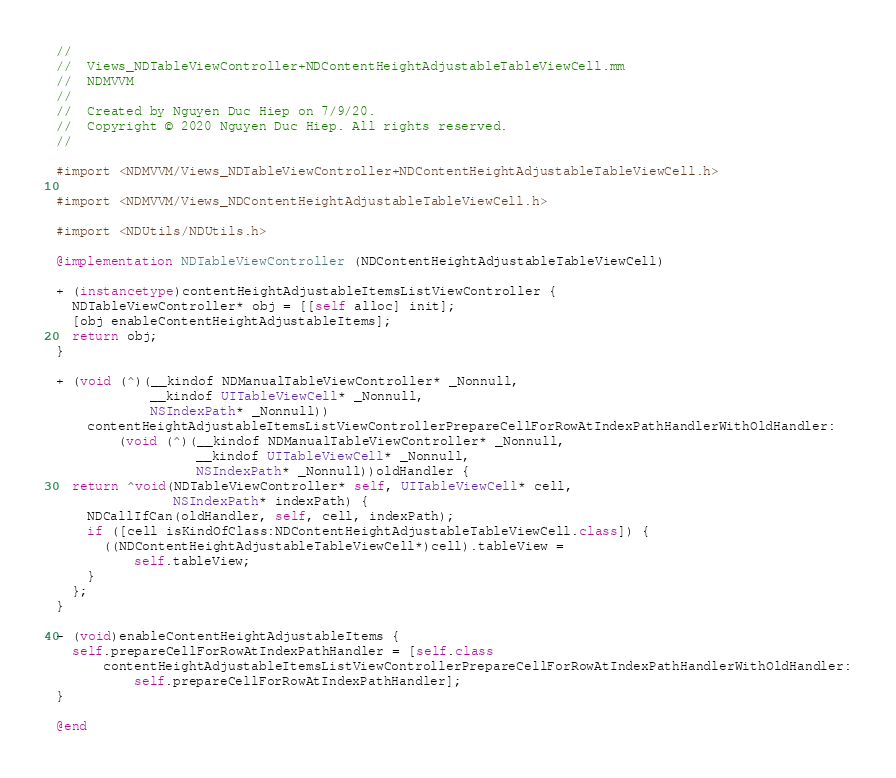Convert code to text. <code><loc_0><loc_0><loc_500><loc_500><_ObjectiveC_>//
//  Views_NDTableViewController+NDContentHeightAdjustableTableViewCell.mm
//  NDMVVM
//
//  Created by Nguyen Duc Hiep on 7/9/20.
//  Copyright © 2020 Nguyen Duc Hiep. All rights reserved.
//

#import <NDMVVM/Views_NDTableViewController+NDContentHeightAdjustableTableViewCell.h>

#import <NDMVVM/Views_NDContentHeightAdjustableTableViewCell.h>

#import <NDUtils/NDUtils.h>

@implementation NDTableViewController (NDContentHeightAdjustableTableViewCell)

+ (instancetype)contentHeightAdjustableItemsListViewController {
  NDTableViewController* obj = [[self alloc] init];
  [obj enableContentHeightAdjustableItems];
  return obj;
}

+ (void (^)(__kindof NDManualTableViewController* _Nonnull,
            __kindof UITableViewCell* _Nonnull,
            NSIndexPath* _Nonnull))
    contentHeightAdjustableItemsListViewControllerPrepareCellForRowAtIndexPathHandlerWithOldHandler:
        (void (^)(__kindof NDManualTableViewController* _Nonnull,
                  __kindof UITableViewCell* _Nonnull,
                  NSIndexPath* _Nonnull))oldHandler {
  return ^void(NDTableViewController* self, UITableViewCell* cell,
               NSIndexPath* indexPath) {
    NDCallIfCan(oldHandler, self, cell, indexPath);
    if ([cell isKindOfClass:NDContentHeightAdjustableTableViewCell.class]) {
      ((NDContentHeightAdjustableTableViewCell*)cell).tableView =
          self.tableView;
    }
  };
}

- (void)enableContentHeightAdjustableItems {
  self.prepareCellForRowAtIndexPathHandler = [self.class
      contentHeightAdjustableItemsListViewControllerPrepareCellForRowAtIndexPathHandlerWithOldHandler:
          self.prepareCellForRowAtIndexPathHandler];
}

@end
</code> 